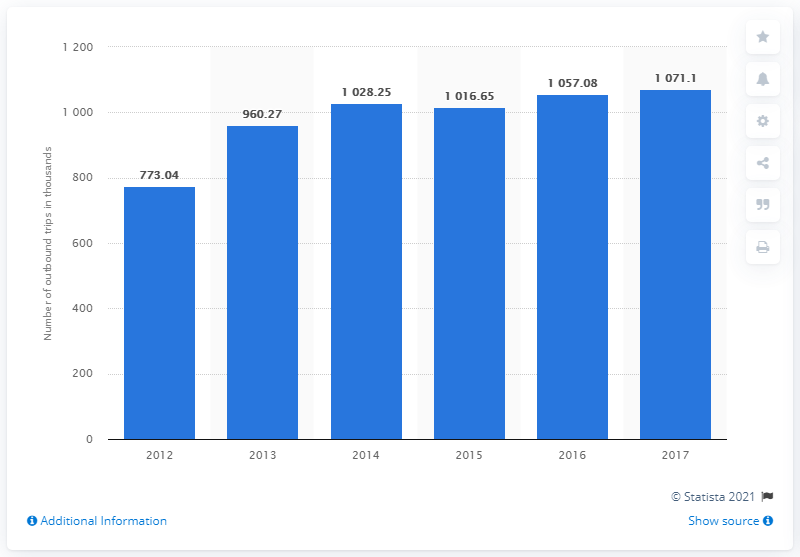List a handful of essential elements in this visual. The number of outbound overnight trips from Romania ended in 2017. 